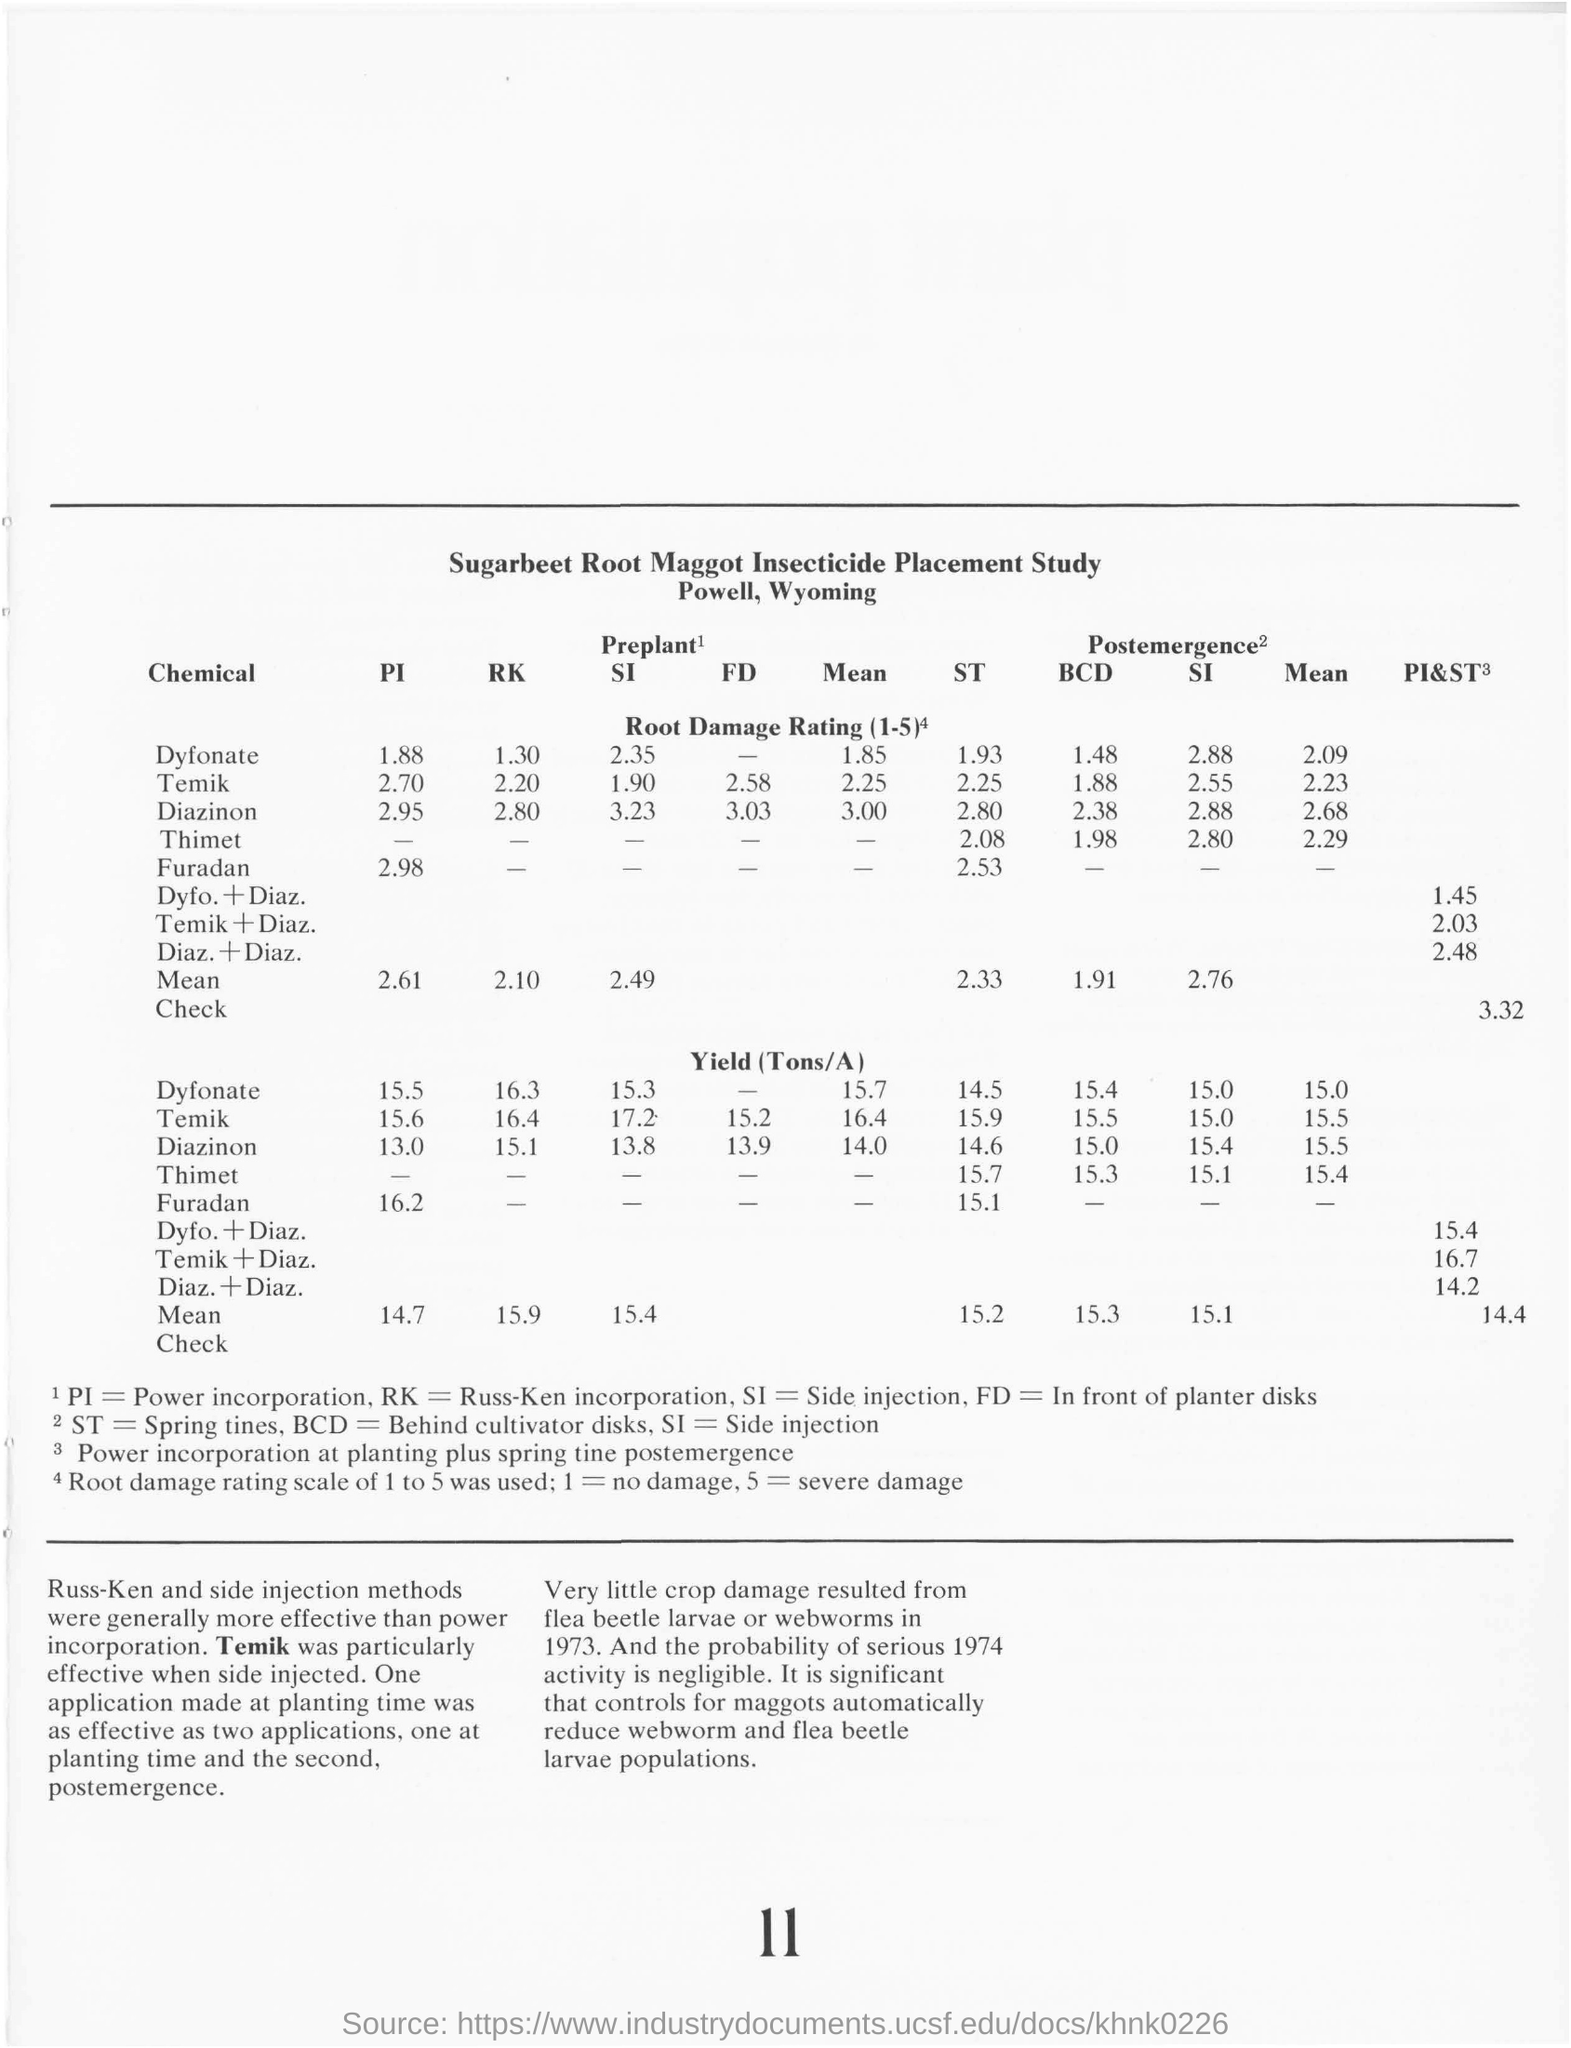Indicate a few pertinent items in this graphic. We are inquiring about the average yield of crops when using Dynate at preplant time, specifically the amount of Tons/A that would be produced. The mean value of this yield is 15.7. The Russ-Ken and side injection methods were found to be more effective than power incorporation in a study on the effectiveness of different methods for bonding metal to ceramic. BCD stands for "Behind Cultivator disks," a term used to describe a specific type of agricultural machinery used in farming. The root damage rating for Diazinon by the side injection method at postemergence time is 2.88. The yield, measured in tons per acre, achieved using Temik at preplant time by the RK method was 16.4. 